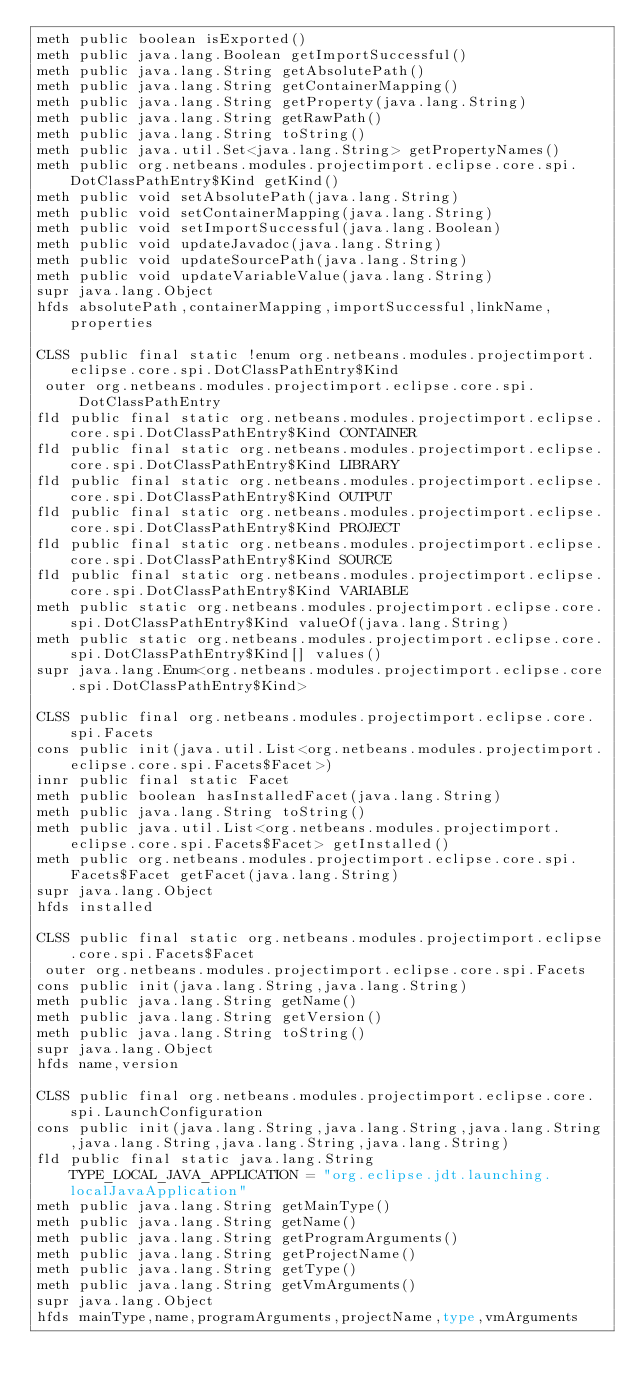Convert code to text. <code><loc_0><loc_0><loc_500><loc_500><_SML_>meth public boolean isExported()
meth public java.lang.Boolean getImportSuccessful()
meth public java.lang.String getAbsolutePath()
meth public java.lang.String getContainerMapping()
meth public java.lang.String getProperty(java.lang.String)
meth public java.lang.String getRawPath()
meth public java.lang.String toString()
meth public java.util.Set<java.lang.String> getPropertyNames()
meth public org.netbeans.modules.projectimport.eclipse.core.spi.DotClassPathEntry$Kind getKind()
meth public void setAbsolutePath(java.lang.String)
meth public void setContainerMapping(java.lang.String)
meth public void setImportSuccessful(java.lang.Boolean)
meth public void updateJavadoc(java.lang.String)
meth public void updateSourcePath(java.lang.String)
meth public void updateVariableValue(java.lang.String)
supr java.lang.Object
hfds absolutePath,containerMapping,importSuccessful,linkName,properties

CLSS public final static !enum org.netbeans.modules.projectimport.eclipse.core.spi.DotClassPathEntry$Kind
 outer org.netbeans.modules.projectimport.eclipse.core.spi.DotClassPathEntry
fld public final static org.netbeans.modules.projectimport.eclipse.core.spi.DotClassPathEntry$Kind CONTAINER
fld public final static org.netbeans.modules.projectimport.eclipse.core.spi.DotClassPathEntry$Kind LIBRARY
fld public final static org.netbeans.modules.projectimport.eclipse.core.spi.DotClassPathEntry$Kind OUTPUT
fld public final static org.netbeans.modules.projectimport.eclipse.core.spi.DotClassPathEntry$Kind PROJECT
fld public final static org.netbeans.modules.projectimport.eclipse.core.spi.DotClassPathEntry$Kind SOURCE
fld public final static org.netbeans.modules.projectimport.eclipse.core.spi.DotClassPathEntry$Kind VARIABLE
meth public static org.netbeans.modules.projectimport.eclipse.core.spi.DotClassPathEntry$Kind valueOf(java.lang.String)
meth public static org.netbeans.modules.projectimport.eclipse.core.spi.DotClassPathEntry$Kind[] values()
supr java.lang.Enum<org.netbeans.modules.projectimport.eclipse.core.spi.DotClassPathEntry$Kind>

CLSS public final org.netbeans.modules.projectimport.eclipse.core.spi.Facets
cons public init(java.util.List<org.netbeans.modules.projectimport.eclipse.core.spi.Facets$Facet>)
innr public final static Facet
meth public boolean hasInstalledFacet(java.lang.String)
meth public java.lang.String toString()
meth public java.util.List<org.netbeans.modules.projectimport.eclipse.core.spi.Facets$Facet> getInstalled()
meth public org.netbeans.modules.projectimport.eclipse.core.spi.Facets$Facet getFacet(java.lang.String)
supr java.lang.Object
hfds installed

CLSS public final static org.netbeans.modules.projectimport.eclipse.core.spi.Facets$Facet
 outer org.netbeans.modules.projectimport.eclipse.core.spi.Facets
cons public init(java.lang.String,java.lang.String)
meth public java.lang.String getName()
meth public java.lang.String getVersion()
meth public java.lang.String toString()
supr java.lang.Object
hfds name,version

CLSS public final org.netbeans.modules.projectimport.eclipse.core.spi.LaunchConfiguration
cons public init(java.lang.String,java.lang.String,java.lang.String,java.lang.String,java.lang.String,java.lang.String)
fld public final static java.lang.String TYPE_LOCAL_JAVA_APPLICATION = "org.eclipse.jdt.launching.localJavaApplication"
meth public java.lang.String getMainType()
meth public java.lang.String getName()
meth public java.lang.String getProgramArguments()
meth public java.lang.String getProjectName()
meth public java.lang.String getType()
meth public java.lang.String getVmArguments()
supr java.lang.Object
hfds mainType,name,programArguments,projectName,type,vmArguments
</code> 